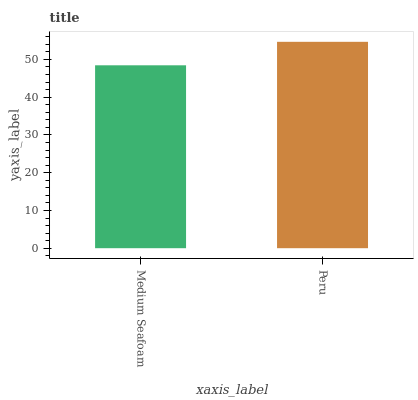Is Medium Seafoam the minimum?
Answer yes or no. Yes. Is Peru the maximum?
Answer yes or no. Yes. Is Peru the minimum?
Answer yes or no. No. Is Peru greater than Medium Seafoam?
Answer yes or no. Yes. Is Medium Seafoam less than Peru?
Answer yes or no. Yes. Is Medium Seafoam greater than Peru?
Answer yes or no. No. Is Peru less than Medium Seafoam?
Answer yes or no. No. Is Peru the high median?
Answer yes or no. Yes. Is Medium Seafoam the low median?
Answer yes or no. Yes. Is Medium Seafoam the high median?
Answer yes or no. No. Is Peru the low median?
Answer yes or no. No. 